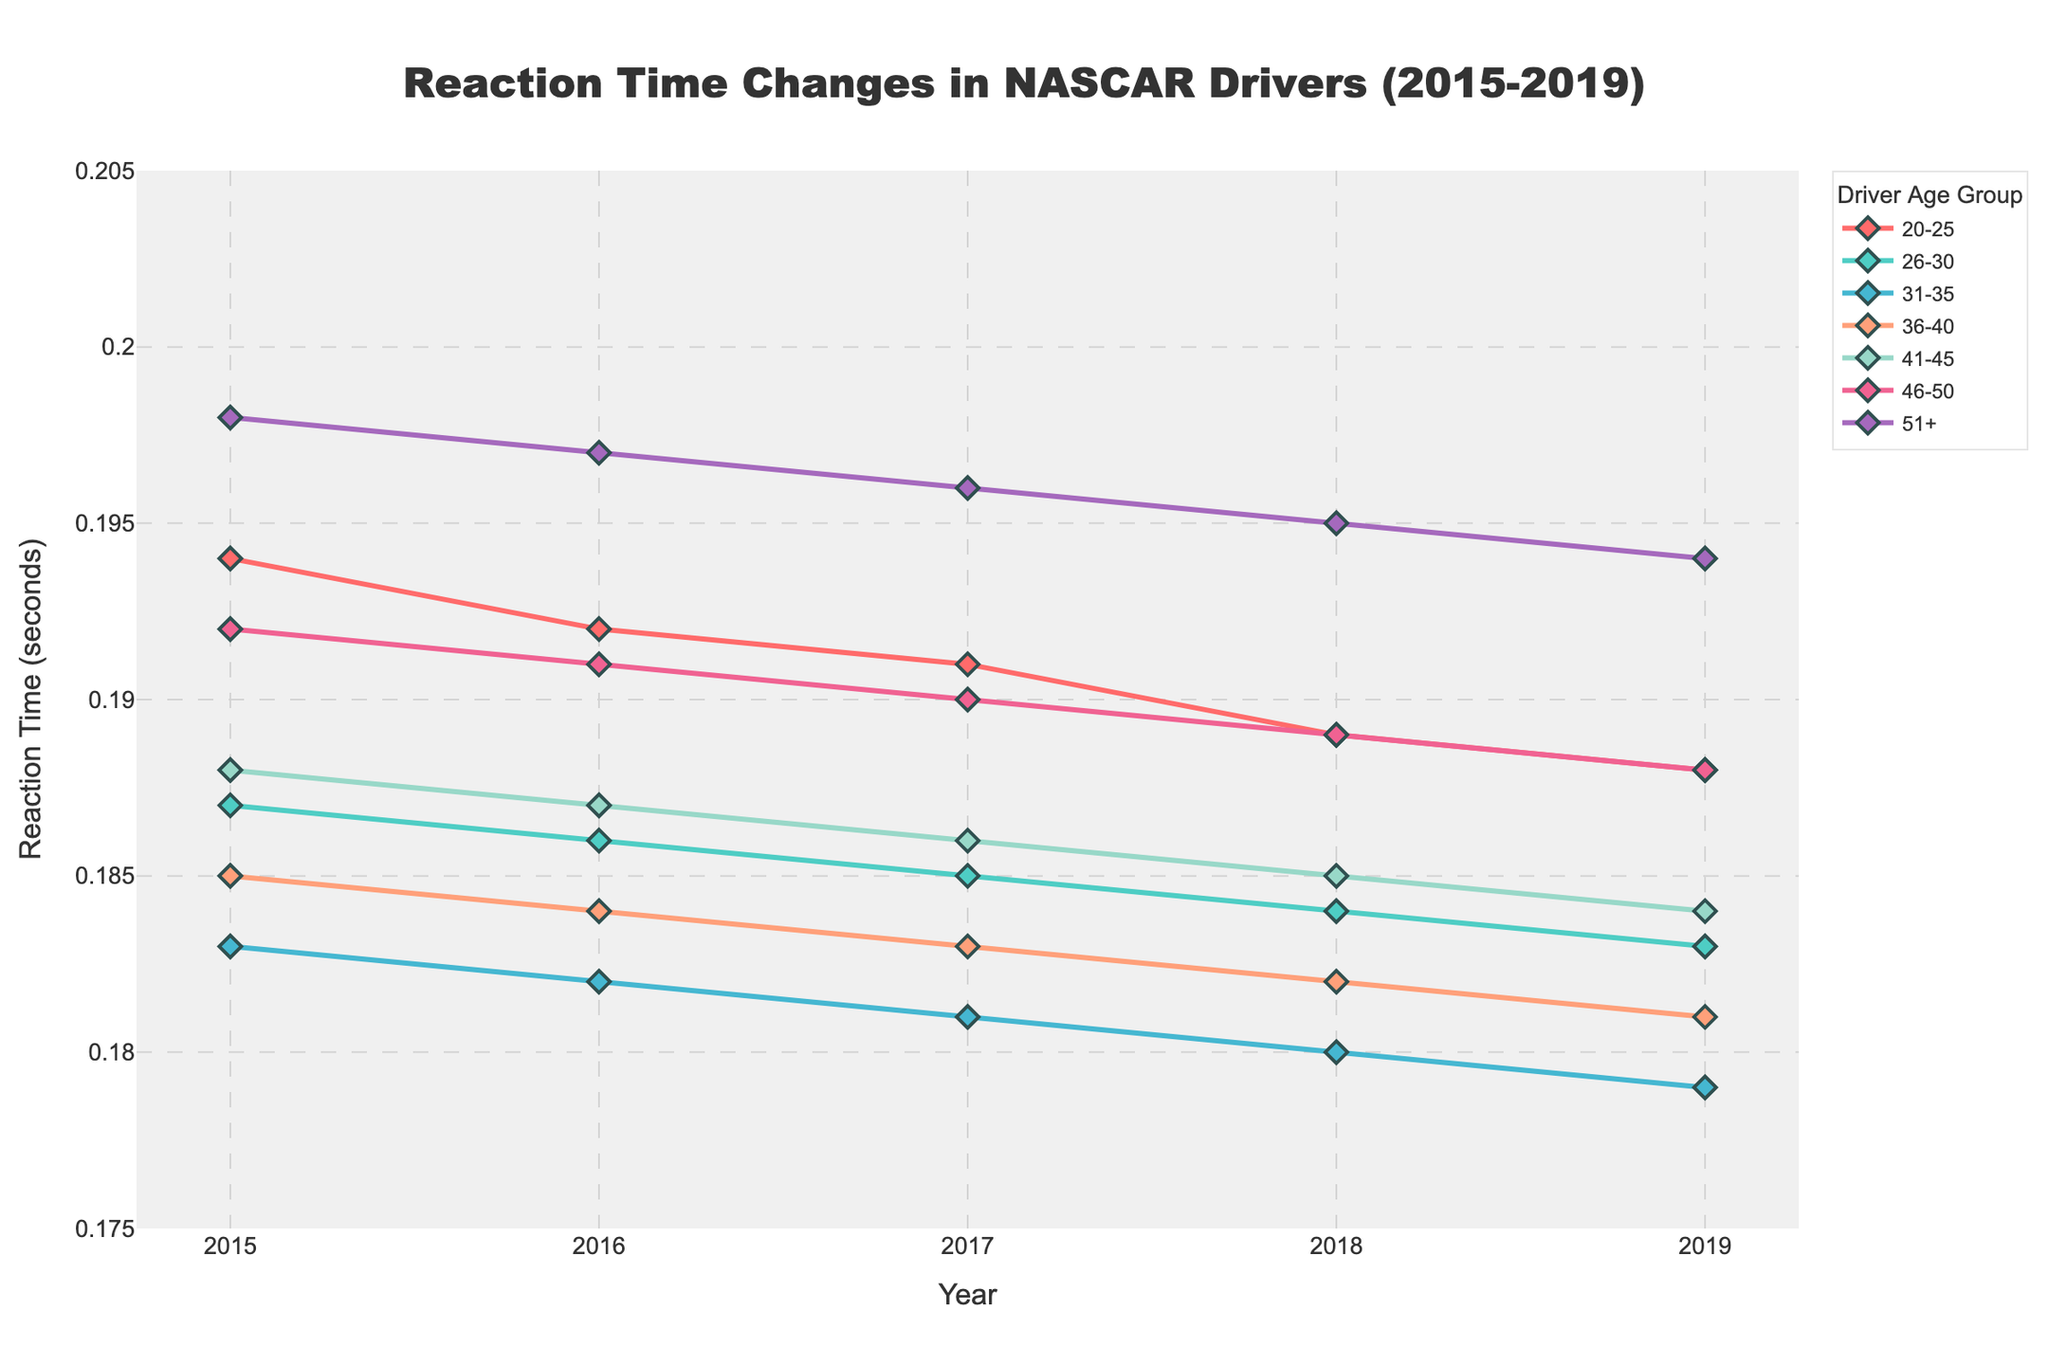What's the trend in reaction times for drivers aged 20-25 from 2015 to 2019? The trend can be seen by observing the line for the '20-25' age group from 2015 to 2019. In each year, their reaction time shows a decrease: 0.194 seconds in 2015, 0.192 in 2016, 0.191 in 2017, 0.189 in 2018, and 0.188 in 2019. This indicates a consistent improvement.
Answer: Decreasing trend Which age group has the fastest reaction time in 2019? Compare the reaction times in 2019 for each age group. The age group 31-35 has the lowest reaction time of 0.179 seconds.
Answer: 31-35 How much did the reaction time for the 51+ age group improve from 2015 to 2019? Subtract the reaction time of 2019 (0.194 seconds) from that of 2015 (0.198 seconds). The improvement is 0.198 - 0.194 = 0.004 seconds.
Answer: 0.004 seconds Which age group showed the least change in reaction time from 2015 to 2019? Compare the change in reaction times for each age group by finding the difference between their 2015 and 2019 values. The '36-40' age group showed the smallest decrease from 0.185 seconds in 2015 to 0.181 in 2019, a difference of 0.004 seconds.
Answer: 36-40 How does the reaction time change from 2015 to 2019 for drivers aged 26-30 compare to those aged 46-50? Calculate the change for both groups. For 26-30, the difference is 0.187 - 0.183 = 0.004 seconds. For 46-50, it is 0.192 - 0.188 = 0.004 seconds. Both age groups show the same improvement of 0.004 seconds.
Answer: Same improvement Which age group's reaction time showed a greater decrease between 2015 and 2019: 20-25 or 51+? Calculate the change for both groups. For 20-25, the difference is 0.194 - 0.188 = 0.006 seconds. For 51+, the difference is 0.198 - 0.194 = 0.004 seconds. The 20-25 age group showed a greater decrease.
Answer: 20-25 Rank the age groups based on their reaction times in 2017 from fastest to slowest. Compare reaction times for all age groups in 2017: 31-35 (0.181), 36-40 (0.183), 26-30 (0.185), 41-45 (0.186), 46-50 (0.190), 51+ (0.196), and 20-25 (0.191). The rank from fastest to slowest is: 31-35, 36-40, 26-30, 41-45, 20-25, 46-50, 51+.
Answer: 31-35, 36-40, 26-30, 41-45, 20-25, 46-50, 51+ What color represents the 31-35 age group in the plot? Observe the plot legend where each age group is associated with a color. The 31-35 age group is represented by the yellow-greenish color.
Answer: Yellow-greenish color 